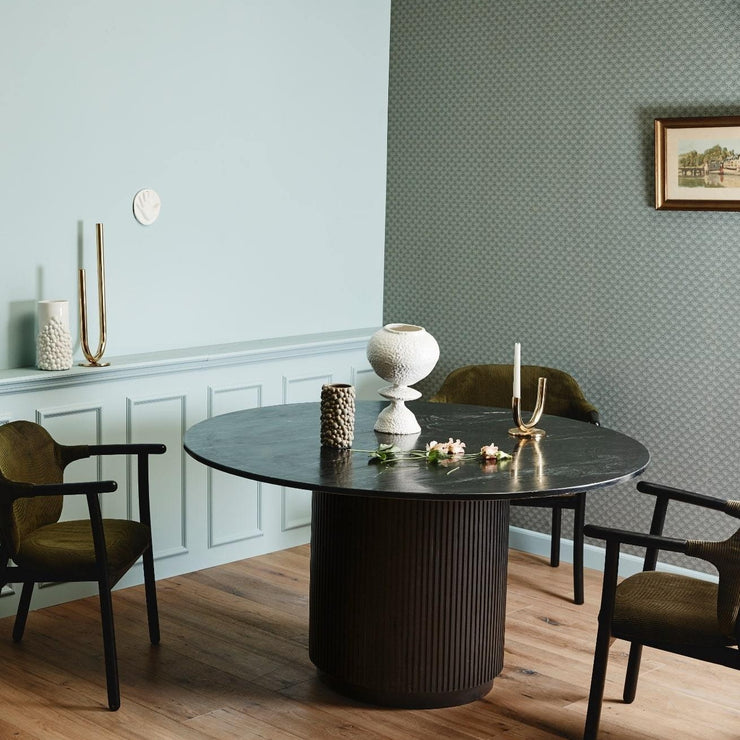How many chairs would there be in the image after two more chairs have been added in the image? There are currently three chairs visible in the image. If two more chairs are added to the scene, there would be a total of five chairs. This assumes the additional chairs are of a similar design and size and can be accommodated around the table within the space present in the room. 